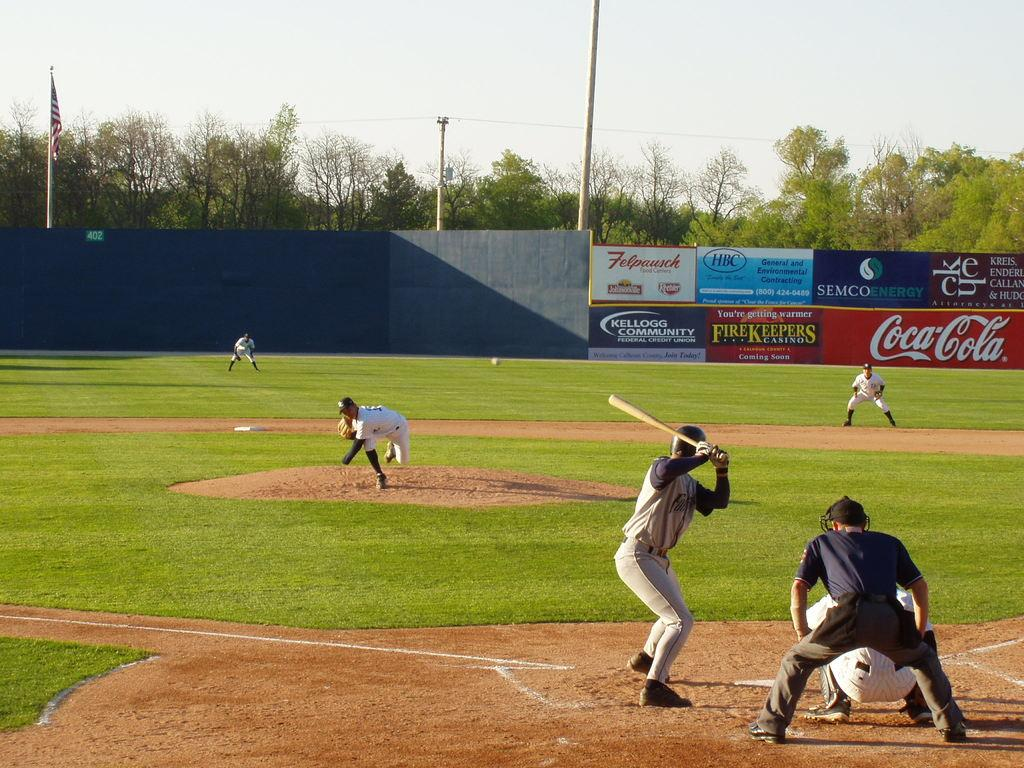<image>
Write a terse but informative summary of the picture. A baseball field with advertising from Falpausch and Kellogg Community Federal Credit Union. 